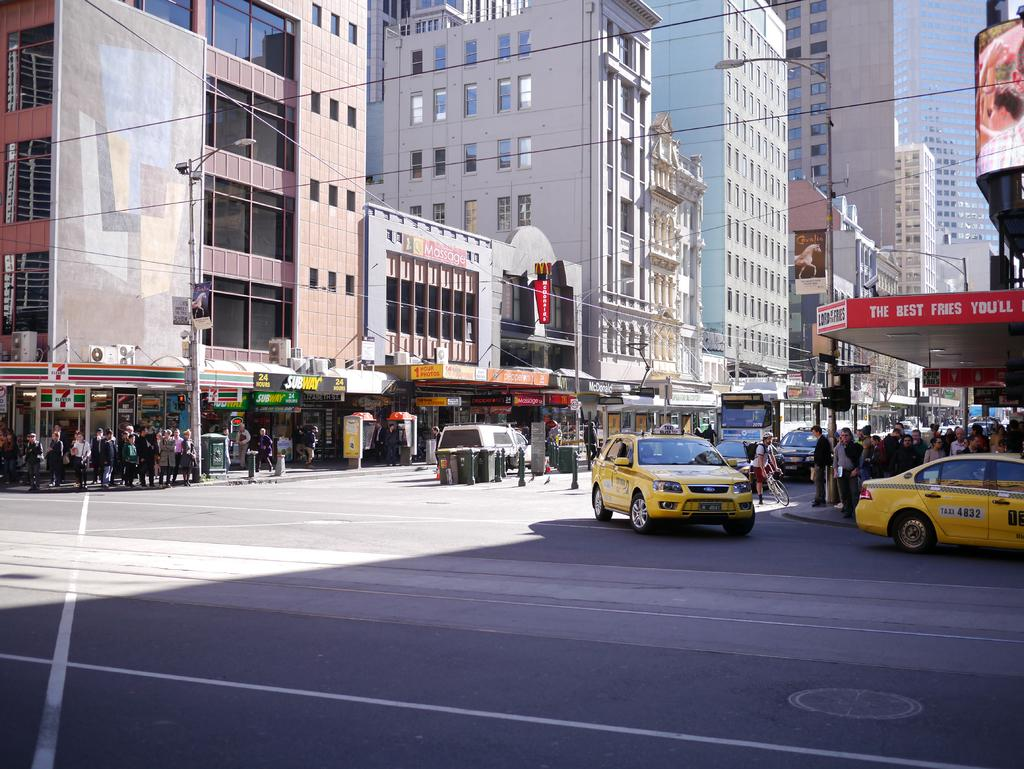<image>
Relay a brief, clear account of the picture shown. A store called Lord of the Fries is on the corner with some Taxis in front of it. 